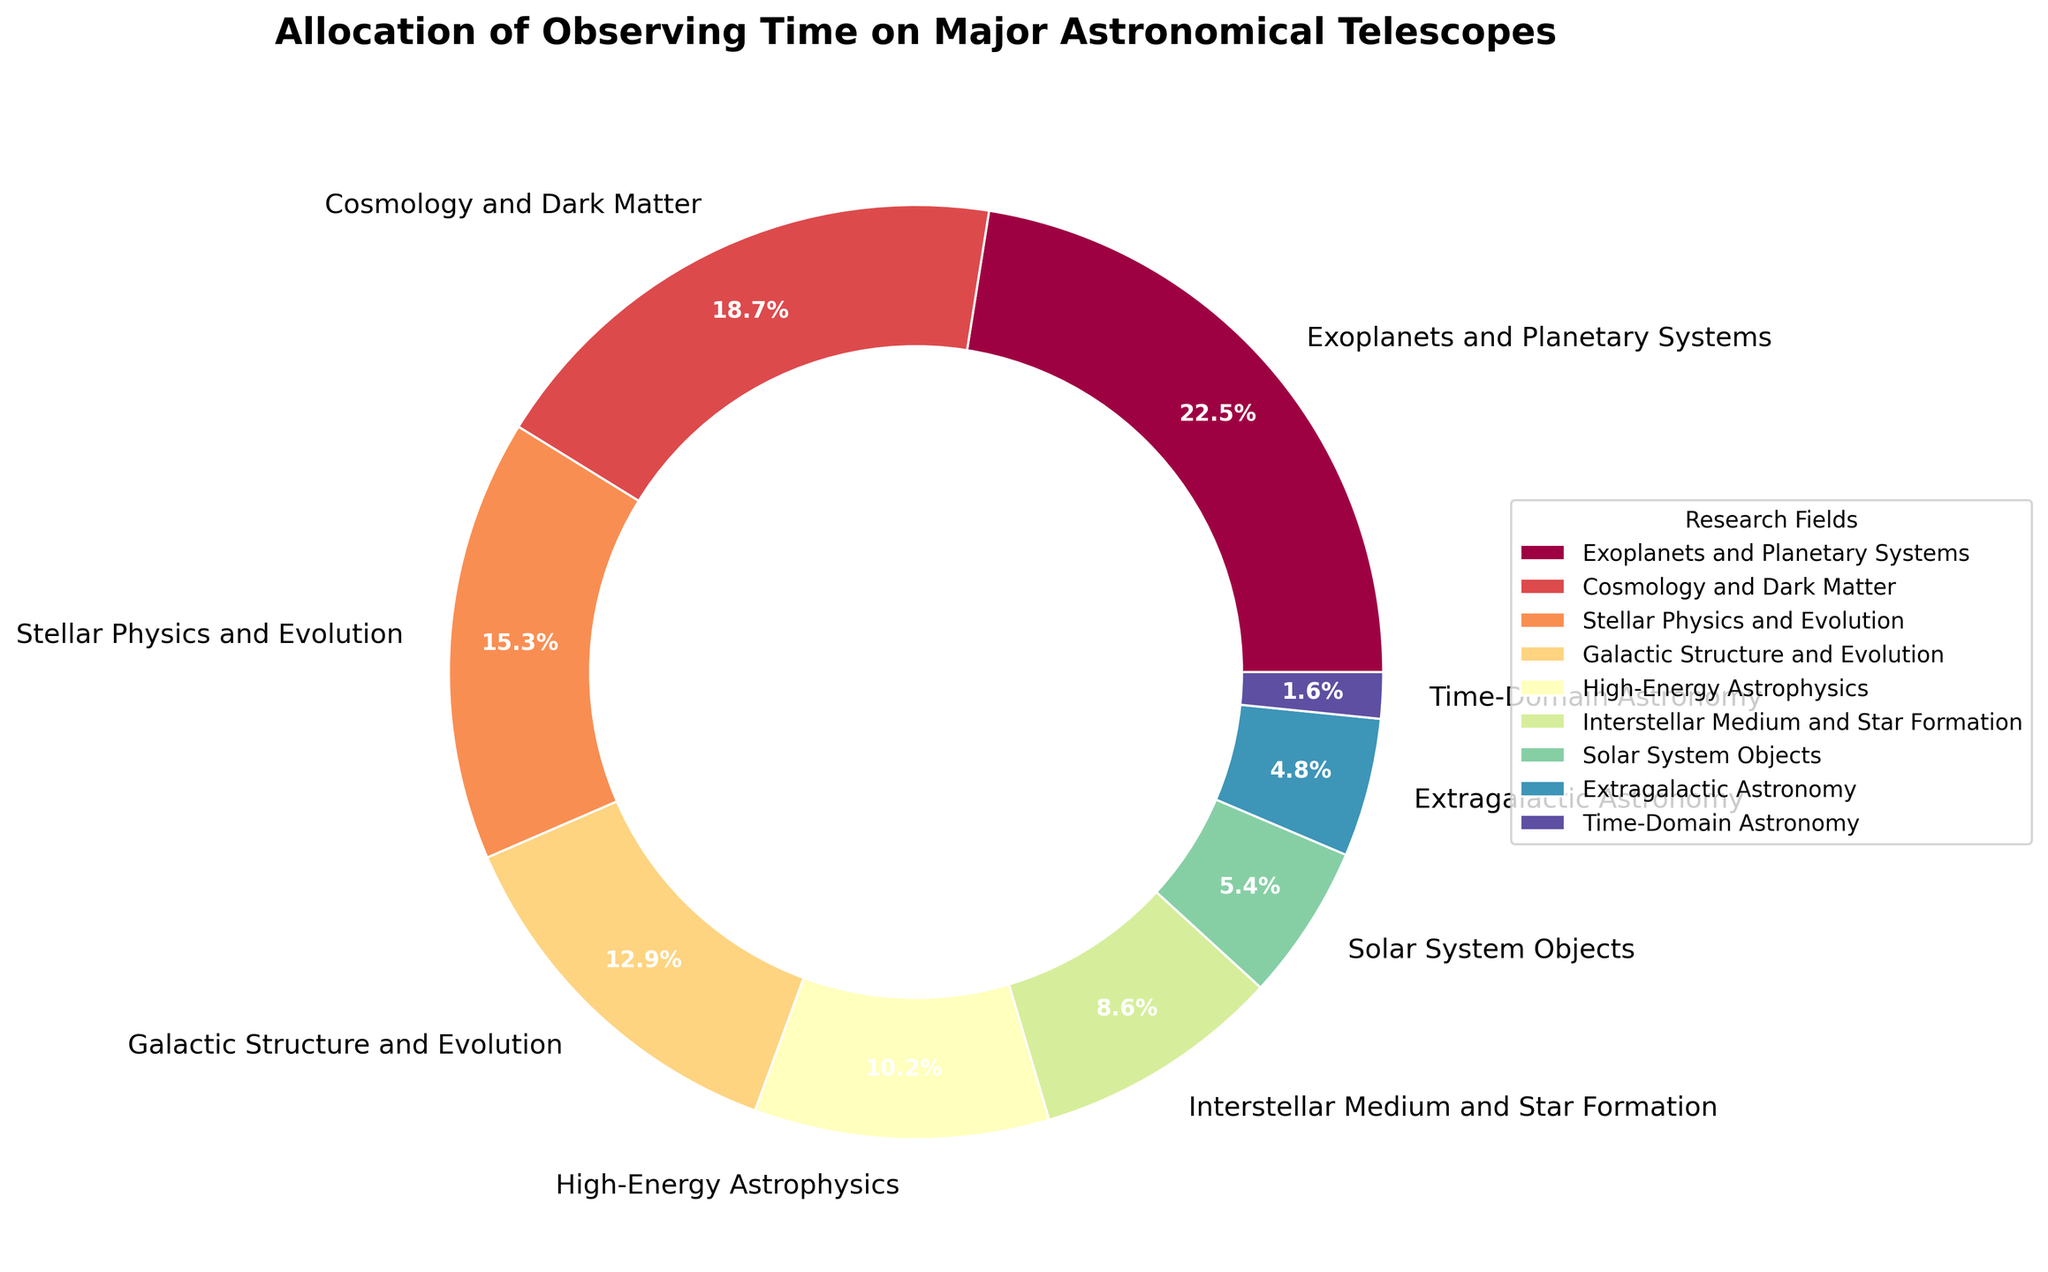What percentage of observing time is allocated to Extragalactic Astronomy? Refer to the slice labeled "Extragalactic Astronomy" and look at its percentage label.
Answer: 4.8% Which research field receives the most observing time? Identify the research field with the largest slice in the pie chart and the highest percentage label.
Answer: Exoplanets and Planetary Systems How much more observing time is allocated to Stellar Physics and Evolution compared to Solar System Objects? Find the percentages for "Stellar Physics and Evolution" and "Solar System Objects," then subtract the latter from the former: 15.3% - 5.4%.
Answer: 9.9% Do Cosmology and Dark Matter receive more or less observing time than Galactic Structure and Evolution? Compare the percentages of "Cosmology and Dark Matter" and "Galactic Structure and Evolution": 18.7% vs. 12.9%.
Answer: More Which research fields receive less than 10% of observing time each? Identify the slices with a percentage label less than 10%.
Answer: High-Energy Astrophysics, Interstellar Medium and Star Formation, Solar System Objects, Extragalactic Astronomy, Time-Domain Astronomy What is the combined percentage of observing time for High-Energy Astrophysics and Interstellar Medium and Star Formation? Add the percentages of "High-Energy Astrophysics" and "Interstellar Medium and Star Formation": 10.2% + 8.6%.
Answer: 18.8% How many slices are there in the pie chart that represent research fields with exactly or more than 5% but less than 20% of observing time? Count the slices with percentages within the specified range: 7 (Cosmology and Dark Matter, Stellar Physics and Evolution, Galactic Structure and Evolution, High-Energy Astrophysics, Interstellar Medium and Star Formation, Solar System Objects, Extragalactic Astronomy).
Answer: 7 What percentage of the total observing time is allocated to the top two research fields combined? Add the percentages of the top two research fields: 22.5% (Exoplanets and Planetary Systems) + 18.7% (Cosmology and Dark Matter).
Answer: 41.2% Among the research fields, which one has been allocated the least observing time? Identify the slice with the smallest percentage label: "Time-Domain Astronomy."
Answer: Time-Domain Astronomy What percentage more observing time is given to Exoplanets and Planetary Systems compared to Time-Domain Astronomy? Subtract the percentage for "Time-Domain Astronomy" from that for "Exoplanets and Planetary Systems": 22.5% - 1.6%.
Answer: 20.9% 